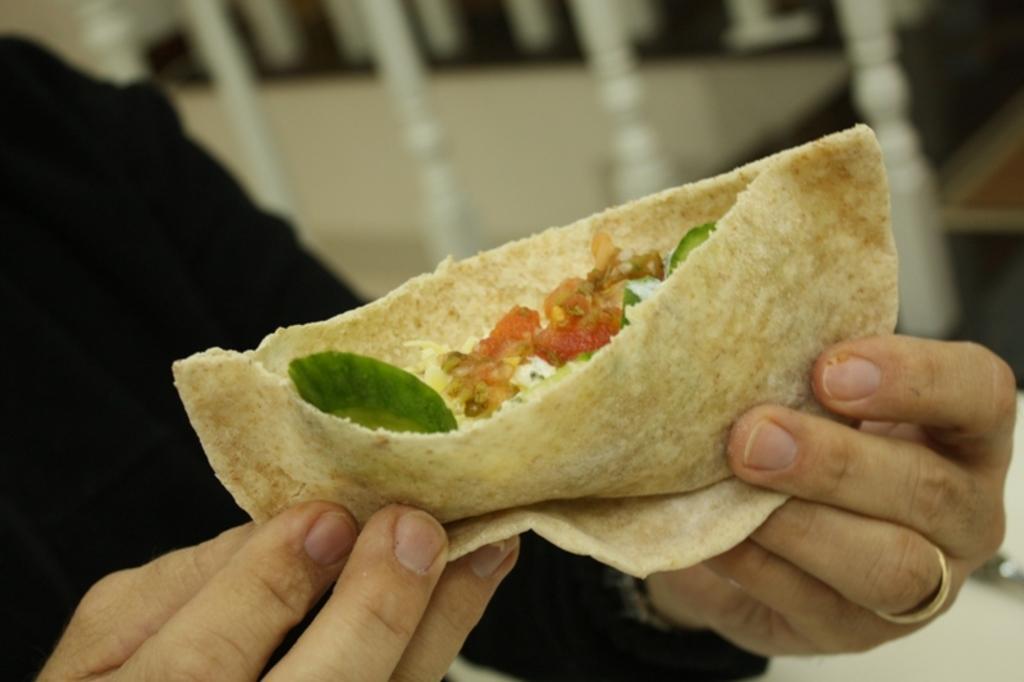Could you give a brief overview of what you see in this image? In this picture I can see a human holding food in his hand and I can see a fence on the side. 